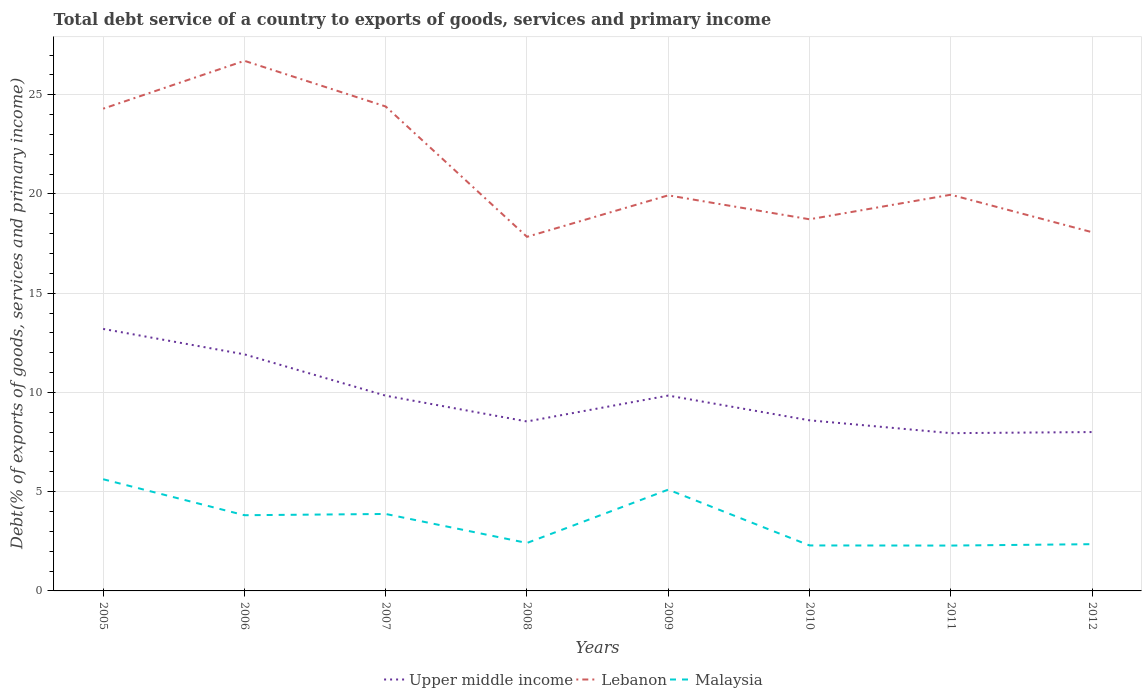Does the line corresponding to Upper middle income intersect with the line corresponding to Malaysia?
Keep it short and to the point. No. Across all years, what is the maximum total debt service in Lebanon?
Offer a very short reply. 17.84. What is the total total debt service in Lebanon in the graph?
Offer a terse response. -0.23. What is the difference between the highest and the second highest total debt service in Upper middle income?
Your answer should be compact. 5.25. What is the difference between the highest and the lowest total debt service in Malaysia?
Make the answer very short. 4. How many years are there in the graph?
Provide a short and direct response. 8. What is the difference between two consecutive major ticks on the Y-axis?
Provide a short and direct response. 5. Does the graph contain grids?
Ensure brevity in your answer.  Yes. Where does the legend appear in the graph?
Keep it short and to the point. Bottom center. How many legend labels are there?
Your response must be concise. 3. What is the title of the graph?
Your answer should be very brief. Total debt service of a country to exports of goods, services and primary income. What is the label or title of the X-axis?
Provide a short and direct response. Years. What is the label or title of the Y-axis?
Provide a succinct answer. Debt(% of exports of goods, services and primary income). What is the Debt(% of exports of goods, services and primary income) of Upper middle income in 2005?
Your answer should be very brief. 13.2. What is the Debt(% of exports of goods, services and primary income) in Lebanon in 2005?
Your response must be concise. 24.3. What is the Debt(% of exports of goods, services and primary income) in Malaysia in 2005?
Provide a short and direct response. 5.63. What is the Debt(% of exports of goods, services and primary income) in Upper middle income in 2006?
Offer a terse response. 11.92. What is the Debt(% of exports of goods, services and primary income) of Lebanon in 2006?
Provide a short and direct response. 26.71. What is the Debt(% of exports of goods, services and primary income) in Malaysia in 2006?
Keep it short and to the point. 3.81. What is the Debt(% of exports of goods, services and primary income) of Upper middle income in 2007?
Your answer should be very brief. 9.84. What is the Debt(% of exports of goods, services and primary income) in Lebanon in 2007?
Your answer should be compact. 24.41. What is the Debt(% of exports of goods, services and primary income) of Malaysia in 2007?
Keep it short and to the point. 3.88. What is the Debt(% of exports of goods, services and primary income) of Upper middle income in 2008?
Your answer should be compact. 8.54. What is the Debt(% of exports of goods, services and primary income) in Lebanon in 2008?
Provide a succinct answer. 17.84. What is the Debt(% of exports of goods, services and primary income) of Malaysia in 2008?
Provide a short and direct response. 2.42. What is the Debt(% of exports of goods, services and primary income) of Upper middle income in 2009?
Your answer should be compact. 9.84. What is the Debt(% of exports of goods, services and primary income) in Lebanon in 2009?
Offer a very short reply. 19.93. What is the Debt(% of exports of goods, services and primary income) in Malaysia in 2009?
Ensure brevity in your answer.  5.1. What is the Debt(% of exports of goods, services and primary income) of Upper middle income in 2010?
Your response must be concise. 8.6. What is the Debt(% of exports of goods, services and primary income) of Lebanon in 2010?
Offer a very short reply. 18.72. What is the Debt(% of exports of goods, services and primary income) of Malaysia in 2010?
Your answer should be compact. 2.29. What is the Debt(% of exports of goods, services and primary income) in Upper middle income in 2011?
Provide a short and direct response. 7.95. What is the Debt(% of exports of goods, services and primary income) in Lebanon in 2011?
Keep it short and to the point. 19.96. What is the Debt(% of exports of goods, services and primary income) in Malaysia in 2011?
Your answer should be very brief. 2.29. What is the Debt(% of exports of goods, services and primary income) of Upper middle income in 2012?
Make the answer very short. 8. What is the Debt(% of exports of goods, services and primary income) of Lebanon in 2012?
Keep it short and to the point. 18.07. What is the Debt(% of exports of goods, services and primary income) of Malaysia in 2012?
Ensure brevity in your answer.  2.35. Across all years, what is the maximum Debt(% of exports of goods, services and primary income) of Upper middle income?
Your answer should be very brief. 13.2. Across all years, what is the maximum Debt(% of exports of goods, services and primary income) of Lebanon?
Offer a very short reply. 26.71. Across all years, what is the maximum Debt(% of exports of goods, services and primary income) of Malaysia?
Provide a succinct answer. 5.63. Across all years, what is the minimum Debt(% of exports of goods, services and primary income) in Upper middle income?
Your response must be concise. 7.95. Across all years, what is the minimum Debt(% of exports of goods, services and primary income) of Lebanon?
Your response must be concise. 17.84. Across all years, what is the minimum Debt(% of exports of goods, services and primary income) in Malaysia?
Your response must be concise. 2.29. What is the total Debt(% of exports of goods, services and primary income) of Upper middle income in the graph?
Make the answer very short. 77.88. What is the total Debt(% of exports of goods, services and primary income) in Lebanon in the graph?
Your answer should be very brief. 169.94. What is the total Debt(% of exports of goods, services and primary income) in Malaysia in the graph?
Your answer should be compact. 27.77. What is the difference between the Debt(% of exports of goods, services and primary income) of Upper middle income in 2005 and that in 2006?
Ensure brevity in your answer.  1.28. What is the difference between the Debt(% of exports of goods, services and primary income) of Lebanon in 2005 and that in 2006?
Ensure brevity in your answer.  -2.41. What is the difference between the Debt(% of exports of goods, services and primary income) of Malaysia in 2005 and that in 2006?
Provide a short and direct response. 1.81. What is the difference between the Debt(% of exports of goods, services and primary income) of Upper middle income in 2005 and that in 2007?
Provide a short and direct response. 3.36. What is the difference between the Debt(% of exports of goods, services and primary income) in Lebanon in 2005 and that in 2007?
Provide a short and direct response. -0.11. What is the difference between the Debt(% of exports of goods, services and primary income) of Malaysia in 2005 and that in 2007?
Your answer should be compact. 1.75. What is the difference between the Debt(% of exports of goods, services and primary income) of Upper middle income in 2005 and that in 2008?
Your response must be concise. 4.66. What is the difference between the Debt(% of exports of goods, services and primary income) in Lebanon in 2005 and that in 2008?
Make the answer very short. 6.46. What is the difference between the Debt(% of exports of goods, services and primary income) of Malaysia in 2005 and that in 2008?
Your answer should be very brief. 3.21. What is the difference between the Debt(% of exports of goods, services and primary income) in Upper middle income in 2005 and that in 2009?
Your answer should be very brief. 3.36. What is the difference between the Debt(% of exports of goods, services and primary income) of Lebanon in 2005 and that in 2009?
Offer a very short reply. 4.37. What is the difference between the Debt(% of exports of goods, services and primary income) in Malaysia in 2005 and that in 2009?
Offer a very short reply. 0.52. What is the difference between the Debt(% of exports of goods, services and primary income) of Upper middle income in 2005 and that in 2010?
Ensure brevity in your answer.  4.6. What is the difference between the Debt(% of exports of goods, services and primary income) of Lebanon in 2005 and that in 2010?
Keep it short and to the point. 5.57. What is the difference between the Debt(% of exports of goods, services and primary income) of Malaysia in 2005 and that in 2010?
Provide a succinct answer. 3.34. What is the difference between the Debt(% of exports of goods, services and primary income) in Upper middle income in 2005 and that in 2011?
Give a very brief answer. 5.25. What is the difference between the Debt(% of exports of goods, services and primary income) of Lebanon in 2005 and that in 2011?
Your response must be concise. 4.33. What is the difference between the Debt(% of exports of goods, services and primary income) of Malaysia in 2005 and that in 2011?
Offer a very short reply. 3.34. What is the difference between the Debt(% of exports of goods, services and primary income) in Upper middle income in 2005 and that in 2012?
Keep it short and to the point. 5.2. What is the difference between the Debt(% of exports of goods, services and primary income) in Lebanon in 2005 and that in 2012?
Make the answer very short. 6.22. What is the difference between the Debt(% of exports of goods, services and primary income) in Malaysia in 2005 and that in 2012?
Provide a short and direct response. 3.27. What is the difference between the Debt(% of exports of goods, services and primary income) in Upper middle income in 2006 and that in 2007?
Offer a very short reply. 2.08. What is the difference between the Debt(% of exports of goods, services and primary income) of Lebanon in 2006 and that in 2007?
Offer a very short reply. 2.3. What is the difference between the Debt(% of exports of goods, services and primary income) in Malaysia in 2006 and that in 2007?
Keep it short and to the point. -0.06. What is the difference between the Debt(% of exports of goods, services and primary income) in Upper middle income in 2006 and that in 2008?
Your answer should be compact. 3.38. What is the difference between the Debt(% of exports of goods, services and primary income) in Lebanon in 2006 and that in 2008?
Offer a terse response. 8.87. What is the difference between the Debt(% of exports of goods, services and primary income) in Malaysia in 2006 and that in 2008?
Your answer should be very brief. 1.4. What is the difference between the Debt(% of exports of goods, services and primary income) of Upper middle income in 2006 and that in 2009?
Keep it short and to the point. 2.08. What is the difference between the Debt(% of exports of goods, services and primary income) of Lebanon in 2006 and that in 2009?
Offer a terse response. 6.78. What is the difference between the Debt(% of exports of goods, services and primary income) of Malaysia in 2006 and that in 2009?
Ensure brevity in your answer.  -1.29. What is the difference between the Debt(% of exports of goods, services and primary income) in Upper middle income in 2006 and that in 2010?
Offer a very short reply. 3.32. What is the difference between the Debt(% of exports of goods, services and primary income) in Lebanon in 2006 and that in 2010?
Ensure brevity in your answer.  7.98. What is the difference between the Debt(% of exports of goods, services and primary income) of Malaysia in 2006 and that in 2010?
Your answer should be very brief. 1.52. What is the difference between the Debt(% of exports of goods, services and primary income) in Upper middle income in 2006 and that in 2011?
Provide a short and direct response. 3.97. What is the difference between the Debt(% of exports of goods, services and primary income) of Lebanon in 2006 and that in 2011?
Offer a very short reply. 6.75. What is the difference between the Debt(% of exports of goods, services and primary income) of Malaysia in 2006 and that in 2011?
Your answer should be compact. 1.53. What is the difference between the Debt(% of exports of goods, services and primary income) of Upper middle income in 2006 and that in 2012?
Give a very brief answer. 3.91. What is the difference between the Debt(% of exports of goods, services and primary income) of Lebanon in 2006 and that in 2012?
Provide a succinct answer. 8.63. What is the difference between the Debt(% of exports of goods, services and primary income) in Malaysia in 2006 and that in 2012?
Keep it short and to the point. 1.46. What is the difference between the Debt(% of exports of goods, services and primary income) in Upper middle income in 2007 and that in 2008?
Provide a succinct answer. 1.3. What is the difference between the Debt(% of exports of goods, services and primary income) in Lebanon in 2007 and that in 2008?
Offer a very short reply. 6.57. What is the difference between the Debt(% of exports of goods, services and primary income) in Malaysia in 2007 and that in 2008?
Offer a very short reply. 1.46. What is the difference between the Debt(% of exports of goods, services and primary income) of Upper middle income in 2007 and that in 2009?
Offer a terse response. -0.01. What is the difference between the Debt(% of exports of goods, services and primary income) in Lebanon in 2007 and that in 2009?
Keep it short and to the point. 4.48. What is the difference between the Debt(% of exports of goods, services and primary income) in Malaysia in 2007 and that in 2009?
Ensure brevity in your answer.  -1.23. What is the difference between the Debt(% of exports of goods, services and primary income) in Upper middle income in 2007 and that in 2010?
Give a very brief answer. 1.24. What is the difference between the Debt(% of exports of goods, services and primary income) of Lebanon in 2007 and that in 2010?
Provide a short and direct response. 5.68. What is the difference between the Debt(% of exports of goods, services and primary income) in Malaysia in 2007 and that in 2010?
Provide a short and direct response. 1.59. What is the difference between the Debt(% of exports of goods, services and primary income) in Upper middle income in 2007 and that in 2011?
Your answer should be very brief. 1.89. What is the difference between the Debt(% of exports of goods, services and primary income) in Lebanon in 2007 and that in 2011?
Make the answer very short. 4.45. What is the difference between the Debt(% of exports of goods, services and primary income) in Malaysia in 2007 and that in 2011?
Your response must be concise. 1.59. What is the difference between the Debt(% of exports of goods, services and primary income) in Upper middle income in 2007 and that in 2012?
Your response must be concise. 1.83. What is the difference between the Debt(% of exports of goods, services and primary income) in Lebanon in 2007 and that in 2012?
Your answer should be compact. 6.33. What is the difference between the Debt(% of exports of goods, services and primary income) of Malaysia in 2007 and that in 2012?
Your answer should be compact. 1.52. What is the difference between the Debt(% of exports of goods, services and primary income) of Upper middle income in 2008 and that in 2009?
Provide a succinct answer. -1.3. What is the difference between the Debt(% of exports of goods, services and primary income) of Lebanon in 2008 and that in 2009?
Give a very brief answer. -2.09. What is the difference between the Debt(% of exports of goods, services and primary income) in Malaysia in 2008 and that in 2009?
Your answer should be compact. -2.69. What is the difference between the Debt(% of exports of goods, services and primary income) in Upper middle income in 2008 and that in 2010?
Ensure brevity in your answer.  -0.06. What is the difference between the Debt(% of exports of goods, services and primary income) of Lebanon in 2008 and that in 2010?
Make the answer very short. -0.88. What is the difference between the Debt(% of exports of goods, services and primary income) of Malaysia in 2008 and that in 2010?
Make the answer very short. 0.12. What is the difference between the Debt(% of exports of goods, services and primary income) of Upper middle income in 2008 and that in 2011?
Your response must be concise. 0.59. What is the difference between the Debt(% of exports of goods, services and primary income) of Lebanon in 2008 and that in 2011?
Ensure brevity in your answer.  -2.12. What is the difference between the Debt(% of exports of goods, services and primary income) of Malaysia in 2008 and that in 2011?
Offer a very short reply. 0.13. What is the difference between the Debt(% of exports of goods, services and primary income) of Upper middle income in 2008 and that in 2012?
Provide a short and direct response. 0.53. What is the difference between the Debt(% of exports of goods, services and primary income) of Lebanon in 2008 and that in 2012?
Your response must be concise. -0.23. What is the difference between the Debt(% of exports of goods, services and primary income) of Malaysia in 2008 and that in 2012?
Ensure brevity in your answer.  0.06. What is the difference between the Debt(% of exports of goods, services and primary income) of Upper middle income in 2009 and that in 2010?
Your answer should be compact. 1.25. What is the difference between the Debt(% of exports of goods, services and primary income) of Lebanon in 2009 and that in 2010?
Offer a very short reply. 1.21. What is the difference between the Debt(% of exports of goods, services and primary income) of Malaysia in 2009 and that in 2010?
Make the answer very short. 2.81. What is the difference between the Debt(% of exports of goods, services and primary income) in Upper middle income in 2009 and that in 2011?
Keep it short and to the point. 1.89. What is the difference between the Debt(% of exports of goods, services and primary income) in Lebanon in 2009 and that in 2011?
Your answer should be very brief. -0.03. What is the difference between the Debt(% of exports of goods, services and primary income) in Malaysia in 2009 and that in 2011?
Your answer should be compact. 2.82. What is the difference between the Debt(% of exports of goods, services and primary income) of Upper middle income in 2009 and that in 2012?
Give a very brief answer. 1.84. What is the difference between the Debt(% of exports of goods, services and primary income) in Lebanon in 2009 and that in 2012?
Offer a terse response. 1.86. What is the difference between the Debt(% of exports of goods, services and primary income) in Malaysia in 2009 and that in 2012?
Give a very brief answer. 2.75. What is the difference between the Debt(% of exports of goods, services and primary income) in Upper middle income in 2010 and that in 2011?
Make the answer very short. 0.65. What is the difference between the Debt(% of exports of goods, services and primary income) of Lebanon in 2010 and that in 2011?
Provide a succinct answer. -1.24. What is the difference between the Debt(% of exports of goods, services and primary income) in Malaysia in 2010 and that in 2011?
Ensure brevity in your answer.  0.01. What is the difference between the Debt(% of exports of goods, services and primary income) of Upper middle income in 2010 and that in 2012?
Keep it short and to the point. 0.59. What is the difference between the Debt(% of exports of goods, services and primary income) of Lebanon in 2010 and that in 2012?
Offer a very short reply. 0.65. What is the difference between the Debt(% of exports of goods, services and primary income) in Malaysia in 2010 and that in 2012?
Keep it short and to the point. -0.06. What is the difference between the Debt(% of exports of goods, services and primary income) of Upper middle income in 2011 and that in 2012?
Ensure brevity in your answer.  -0.06. What is the difference between the Debt(% of exports of goods, services and primary income) in Lebanon in 2011 and that in 2012?
Offer a terse response. 1.89. What is the difference between the Debt(% of exports of goods, services and primary income) in Malaysia in 2011 and that in 2012?
Ensure brevity in your answer.  -0.07. What is the difference between the Debt(% of exports of goods, services and primary income) of Upper middle income in 2005 and the Debt(% of exports of goods, services and primary income) of Lebanon in 2006?
Offer a terse response. -13.51. What is the difference between the Debt(% of exports of goods, services and primary income) in Upper middle income in 2005 and the Debt(% of exports of goods, services and primary income) in Malaysia in 2006?
Your answer should be compact. 9.39. What is the difference between the Debt(% of exports of goods, services and primary income) in Lebanon in 2005 and the Debt(% of exports of goods, services and primary income) in Malaysia in 2006?
Give a very brief answer. 20.48. What is the difference between the Debt(% of exports of goods, services and primary income) in Upper middle income in 2005 and the Debt(% of exports of goods, services and primary income) in Lebanon in 2007?
Offer a terse response. -11.21. What is the difference between the Debt(% of exports of goods, services and primary income) in Upper middle income in 2005 and the Debt(% of exports of goods, services and primary income) in Malaysia in 2007?
Make the answer very short. 9.32. What is the difference between the Debt(% of exports of goods, services and primary income) in Lebanon in 2005 and the Debt(% of exports of goods, services and primary income) in Malaysia in 2007?
Provide a short and direct response. 20.42. What is the difference between the Debt(% of exports of goods, services and primary income) of Upper middle income in 2005 and the Debt(% of exports of goods, services and primary income) of Lebanon in 2008?
Offer a terse response. -4.64. What is the difference between the Debt(% of exports of goods, services and primary income) of Upper middle income in 2005 and the Debt(% of exports of goods, services and primary income) of Malaysia in 2008?
Your answer should be compact. 10.78. What is the difference between the Debt(% of exports of goods, services and primary income) of Lebanon in 2005 and the Debt(% of exports of goods, services and primary income) of Malaysia in 2008?
Ensure brevity in your answer.  21.88. What is the difference between the Debt(% of exports of goods, services and primary income) in Upper middle income in 2005 and the Debt(% of exports of goods, services and primary income) in Lebanon in 2009?
Your answer should be compact. -6.73. What is the difference between the Debt(% of exports of goods, services and primary income) of Upper middle income in 2005 and the Debt(% of exports of goods, services and primary income) of Malaysia in 2009?
Your answer should be very brief. 8.1. What is the difference between the Debt(% of exports of goods, services and primary income) of Lebanon in 2005 and the Debt(% of exports of goods, services and primary income) of Malaysia in 2009?
Your response must be concise. 19.19. What is the difference between the Debt(% of exports of goods, services and primary income) of Upper middle income in 2005 and the Debt(% of exports of goods, services and primary income) of Lebanon in 2010?
Keep it short and to the point. -5.52. What is the difference between the Debt(% of exports of goods, services and primary income) of Upper middle income in 2005 and the Debt(% of exports of goods, services and primary income) of Malaysia in 2010?
Keep it short and to the point. 10.91. What is the difference between the Debt(% of exports of goods, services and primary income) in Lebanon in 2005 and the Debt(% of exports of goods, services and primary income) in Malaysia in 2010?
Keep it short and to the point. 22. What is the difference between the Debt(% of exports of goods, services and primary income) in Upper middle income in 2005 and the Debt(% of exports of goods, services and primary income) in Lebanon in 2011?
Offer a very short reply. -6.76. What is the difference between the Debt(% of exports of goods, services and primary income) in Upper middle income in 2005 and the Debt(% of exports of goods, services and primary income) in Malaysia in 2011?
Your answer should be very brief. 10.91. What is the difference between the Debt(% of exports of goods, services and primary income) in Lebanon in 2005 and the Debt(% of exports of goods, services and primary income) in Malaysia in 2011?
Offer a terse response. 22.01. What is the difference between the Debt(% of exports of goods, services and primary income) in Upper middle income in 2005 and the Debt(% of exports of goods, services and primary income) in Lebanon in 2012?
Provide a short and direct response. -4.87. What is the difference between the Debt(% of exports of goods, services and primary income) in Upper middle income in 2005 and the Debt(% of exports of goods, services and primary income) in Malaysia in 2012?
Keep it short and to the point. 10.85. What is the difference between the Debt(% of exports of goods, services and primary income) of Lebanon in 2005 and the Debt(% of exports of goods, services and primary income) of Malaysia in 2012?
Keep it short and to the point. 21.94. What is the difference between the Debt(% of exports of goods, services and primary income) in Upper middle income in 2006 and the Debt(% of exports of goods, services and primary income) in Lebanon in 2007?
Make the answer very short. -12.49. What is the difference between the Debt(% of exports of goods, services and primary income) of Upper middle income in 2006 and the Debt(% of exports of goods, services and primary income) of Malaysia in 2007?
Provide a short and direct response. 8.04. What is the difference between the Debt(% of exports of goods, services and primary income) in Lebanon in 2006 and the Debt(% of exports of goods, services and primary income) in Malaysia in 2007?
Offer a terse response. 22.83. What is the difference between the Debt(% of exports of goods, services and primary income) of Upper middle income in 2006 and the Debt(% of exports of goods, services and primary income) of Lebanon in 2008?
Give a very brief answer. -5.92. What is the difference between the Debt(% of exports of goods, services and primary income) in Upper middle income in 2006 and the Debt(% of exports of goods, services and primary income) in Malaysia in 2008?
Your response must be concise. 9.5. What is the difference between the Debt(% of exports of goods, services and primary income) in Lebanon in 2006 and the Debt(% of exports of goods, services and primary income) in Malaysia in 2008?
Your response must be concise. 24.29. What is the difference between the Debt(% of exports of goods, services and primary income) in Upper middle income in 2006 and the Debt(% of exports of goods, services and primary income) in Lebanon in 2009?
Provide a short and direct response. -8.01. What is the difference between the Debt(% of exports of goods, services and primary income) of Upper middle income in 2006 and the Debt(% of exports of goods, services and primary income) of Malaysia in 2009?
Give a very brief answer. 6.82. What is the difference between the Debt(% of exports of goods, services and primary income) of Lebanon in 2006 and the Debt(% of exports of goods, services and primary income) of Malaysia in 2009?
Offer a very short reply. 21.6. What is the difference between the Debt(% of exports of goods, services and primary income) in Upper middle income in 2006 and the Debt(% of exports of goods, services and primary income) in Lebanon in 2010?
Give a very brief answer. -6.81. What is the difference between the Debt(% of exports of goods, services and primary income) in Upper middle income in 2006 and the Debt(% of exports of goods, services and primary income) in Malaysia in 2010?
Give a very brief answer. 9.63. What is the difference between the Debt(% of exports of goods, services and primary income) in Lebanon in 2006 and the Debt(% of exports of goods, services and primary income) in Malaysia in 2010?
Your answer should be very brief. 24.42. What is the difference between the Debt(% of exports of goods, services and primary income) of Upper middle income in 2006 and the Debt(% of exports of goods, services and primary income) of Lebanon in 2011?
Provide a succinct answer. -8.04. What is the difference between the Debt(% of exports of goods, services and primary income) of Upper middle income in 2006 and the Debt(% of exports of goods, services and primary income) of Malaysia in 2011?
Keep it short and to the point. 9.63. What is the difference between the Debt(% of exports of goods, services and primary income) of Lebanon in 2006 and the Debt(% of exports of goods, services and primary income) of Malaysia in 2011?
Make the answer very short. 24.42. What is the difference between the Debt(% of exports of goods, services and primary income) of Upper middle income in 2006 and the Debt(% of exports of goods, services and primary income) of Lebanon in 2012?
Your response must be concise. -6.15. What is the difference between the Debt(% of exports of goods, services and primary income) of Upper middle income in 2006 and the Debt(% of exports of goods, services and primary income) of Malaysia in 2012?
Ensure brevity in your answer.  9.56. What is the difference between the Debt(% of exports of goods, services and primary income) of Lebanon in 2006 and the Debt(% of exports of goods, services and primary income) of Malaysia in 2012?
Provide a short and direct response. 24.35. What is the difference between the Debt(% of exports of goods, services and primary income) in Upper middle income in 2007 and the Debt(% of exports of goods, services and primary income) in Lebanon in 2008?
Keep it short and to the point. -8. What is the difference between the Debt(% of exports of goods, services and primary income) of Upper middle income in 2007 and the Debt(% of exports of goods, services and primary income) of Malaysia in 2008?
Provide a short and direct response. 7.42. What is the difference between the Debt(% of exports of goods, services and primary income) in Lebanon in 2007 and the Debt(% of exports of goods, services and primary income) in Malaysia in 2008?
Keep it short and to the point. 21.99. What is the difference between the Debt(% of exports of goods, services and primary income) in Upper middle income in 2007 and the Debt(% of exports of goods, services and primary income) in Lebanon in 2009?
Offer a terse response. -10.09. What is the difference between the Debt(% of exports of goods, services and primary income) in Upper middle income in 2007 and the Debt(% of exports of goods, services and primary income) in Malaysia in 2009?
Give a very brief answer. 4.73. What is the difference between the Debt(% of exports of goods, services and primary income) of Lebanon in 2007 and the Debt(% of exports of goods, services and primary income) of Malaysia in 2009?
Offer a terse response. 19.3. What is the difference between the Debt(% of exports of goods, services and primary income) in Upper middle income in 2007 and the Debt(% of exports of goods, services and primary income) in Lebanon in 2010?
Ensure brevity in your answer.  -8.89. What is the difference between the Debt(% of exports of goods, services and primary income) in Upper middle income in 2007 and the Debt(% of exports of goods, services and primary income) in Malaysia in 2010?
Your response must be concise. 7.54. What is the difference between the Debt(% of exports of goods, services and primary income) of Lebanon in 2007 and the Debt(% of exports of goods, services and primary income) of Malaysia in 2010?
Your answer should be compact. 22.12. What is the difference between the Debt(% of exports of goods, services and primary income) in Upper middle income in 2007 and the Debt(% of exports of goods, services and primary income) in Lebanon in 2011?
Your response must be concise. -10.13. What is the difference between the Debt(% of exports of goods, services and primary income) in Upper middle income in 2007 and the Debt(% of exports of goods, services and primary income) in Malaysia in 2011?
Provide a short and direct response. 7.55. What is the difference between the Debt(% of exports of goods, services and primary income) of Lebanon in 2007 and the Debt(% of exports of goods, services and primary income) of Malaysia in 2011?
Your answer should be very brief. 22.12. What is the difference between the Debt(% of exports of goods, services and primary income) of Upper middle income in 2007 and the Debt(% of exports of goods, services and primary income) of Lebanon in 2012?
Offer a terse response. -8.24. What is the difference between the Debt(% of exports of goods, services and primary income) in Upper middle income in 2007 and the Debt(% of exports of goods, services and primary income) in Malaysia in 2012?
Offer a very short reply. 7.48. What is the difference between the Debt(% of exports of goods, services and primary income) in Lebanon in 2007 and the Debt(% of exports of goods, services and primary income) in Malaysia in 2012?
Offer a terse response. 22.05. What is the difference between the Debt(% of exports of goods, services and primary income) in Upper middle income in 2008 and the Debt(% of exports of goods, services and primary income) in Lebanon in 2009?
Offer a terse response. -11.39. What is the difference between the Debt(% of exports of goods, services and primary income) in Upper middle income in 2008 and the Debt(% of exports of goods, services and primary income) in Malaysia in 2009?
Make the answer very short. 3.43. What is the difference between the Debt(% of exports of goods, services and primary income) of Lebanon in 2008 and the Debt(% of exports of goods, services and primary income) of Malaysia in 2009?
Give a very brief answer. 12.74. What is the difference between the Debt(% of exports of goods, services and primary income) of Upper middle income in 2008 and the Debt(% of exports of goods, services and primary income) of Lebanon in 2010?
Provide a succinct answer. -10.19. What is the difference between the Debt(% of exports of goods, services and primary income) in Upper middle income in 2008 and the Debt(% of exports of goods, services and primary income) in Malaysia in 2010?
Make the answer very short. 6.25. What is the difference between the Debt(% of exports of goods, services and primary income) in Lebanon in 2008 and the Debt(% of exports of goods, services and primary income) in Malaysia in 2010?
Provide a short and direct response. 15.55. What is the difference between the Debt(% of exports of goods, services and primary income) in Upper middle income in 2008 and the Debt(% of exports of goods, services and primary income) in Lebanon in 2011?
Make the answer very short. -11.42. What is the difference between the Debt(% of exports of goods, services and primary income) in Upper middle income in 2008 and the Debt(% of exports of goods, services and primary income) in Malaysia in 2011?
Provide a succinct answer. 6.25. What is the difference between the Debt(% of exports of goods, services and primary income) of Lebanon in 2008 and the Debt(% of exports of goods, services and primary income) of Malaysia in 2011?
Your answer should be very brief. 15.55. What is the difference between the Debt(% of exports of goods, services and primary income) in Upper middle income in 2008 and the Debt(% of exports of goods, services and primary income) in Lebanon in 2012?
Offer a very short reply. -9.54. What is the difference between the Debt(% of exports of goods, services and primary income) in Upper middle income in 2008 and the Debt(% of exports of goods, services and primary income) in Malaysia in 2012?
Provide a succinct answer. 6.18. What is the difference between the Debt(% of exports of goods, services and primary income) of Lebanon in 2008 and the Debt(% of exports of goods, services and primary income) of Malaysia in 2012?
Your response must be concise. 15.49. What is the difference between the Debt(% of exports of goods, services and primary income) in Upper middle income in 2009 and the Debt(% of exports of goods, services and primary income) in Lebanon in 2010?
Your answer should be very brief. -8.88. What is the difference between the Debt(% of exports of goods, services and primary income) in Upper middle income in 2009 and the Debt(% of exports of goods, services and primary income) in Malaysia in 2010?
Provide a short and direct response. 7.55. What is the difference between the Debt(% of exports of goods, services and primary income) of Lebanon in 2009 and the Debt(% of exports of goods, services and primary income) of Malaysia in 2010?
Offer a terse response. 17.64. What is the difference between the Debt(% of exports of goods, services and primary income) in Upper middle income in 2009 and the Debt(% of exports of goods, services and primary income) in Lebanon in 2011?
Your answer should be compact. -10.12. What is the difference between the Debt(% of exports of goods, services and primary income) in Upper middle income in 2009 and the Debt(% of exports of goods, services and primary income) in Malaysia in 2011?
Your answer should be very brief. 7.56. What is the difference between the Debt(% of exports of goods, services and primary income) in Lebanon in 2009 and the Debt(% of exports of goods, services and primary income) in Malaysia in 2011?
Offer a very short reply. 17.65. What is the difference between the Debt(% of exports of goods, services and primary income) of Upper middle income in 2009 and the Debt(% of exports of goods, services and primary income) of Lebanon in 2012?
Keep it short and to the point. -8.23. What is the difference between the Debt(% of exports of goods, services and primary income) of Upper middle income in 2009 and the Debt(% of exports of goods, services and primary income) of Malaysia in 2012?
Offer a very short reply. 7.49. What is the difference between the Debt(% of exports of goods, services and primary income) of Lebanon in 2009 and the Debt(% of exports of goods, services and primary income) of Malaysia in 2012?
Ensure brevity in your answer.  17.58. What is the difference between the Debt(% of exports of goods, services and primary income) in Upper middle income in 2010 and the Debt(% of exports of goods, services and primary income) in Lebanon in 2011?
Ensure brevity in your answer.  -11.37. What is the difference between the Debt(% of exports of goods, services and primary income) of Upper middle income in 2010 and the Debt(% of exports of goods, services and primary income) of Malaysia in 2011?
Offer a terse response. 6.31. What is the difference between the Debt(% of exports of goods, services and primary income) in Lebanon in 2010 and the Debt(% of exports of goods, services and primary income) in Malaysia in 2011?
Ensure brevity in your answer.  16.44. What is the difference between the Debt(% of exports of goods, services and primary income) of Upper middle income in 2010 and the Debt(% of exports of goods, services and primary income) of Lebanon in 2012?
Provide a short and direct response. -9.48. What is the difference between the Debt(% of exports of goods, services and primary income) in Upper middle income in 2010 and the Debt(% of exports of goods, services and primary income) in Malaysia in 2012?
Offer a terse response. 6.24. What is the difference between the Debt(% of exports of goods, services and primary income) in Lebanon in 2010 and the Debt(% of exports of goods, services and primary income) in Malaysia in 2012?
Give a very brief answer. 16.37. What is the difference between the Debt(% of exports of goods, services and primary income) in Upper middle income in 2011 and the Debt(% of exports of goods, services and primary income) in Lebanon in 2012?
Give a very brief answer. -10.13. What is the difference between the Debt(% of exports of goods, services and primary income) of Upper middle income in 2011 and the Debt(% of exports of goods, services and primary income) of Malaysia in 2012?
Offer a very short reply. 5.59. What is the difference between the Debt(% of exports of goods, services and primary income) in Lebanon in 2011 and the Debt(% of exports of goods, services and primary income) in Malaysia in 2012?
Give a very brief answer. 17.61. What is the average Debt(% of exports of goods, services and primary income) of Upper middle income per year?
Ensure brevity in your answer.  9.74. What is the average Debt(% of exports of goods, services and primary income) of Lebanon per year?
Your answer should be compact. 21.24. What is the average Debt(% of exports of goods, services and primary income) in Malaysia per year?
Provide a short and direct response. 3.47. In the year 2005, what is the difference between the Debt(% of exports of goods, services and primary income) of Upper middle income and Debt(% of exports of goods, services and primary income) of Lebanon?
Provide a short and direct response. -11.1. In the year 2005, what is the difference between the Debt(% of exports of goods, services and primary income) in Upper middle income and Debt(% of exports of goods, services and primary income) in Malaysia?
Make the answer very short. 7.57. In the year 2005, what is the difference between the Debt(% of exports of goods, services and primary income) of Lebanon and Debt(% of exports of goods, services and primary income) of Malaysia?
Offer a very short reply. 18.67. In the year 2006, what is the difference between the Debt(% of exports of goods, services and primary income) of Upper middle income and Debt(% of exports of goods, services and primary income) of Lebanon?
Offer a terse response. -14.79. In the year 2006, what is the difference between the Debt(% of exports of goods, services and primary income) in Upper middle income and Debt(% of exports of goods, services and primary income) in Malaysia?
Offer a very short reply. 8.1. In the year 2006, what is the difference between the Debt(% of exports of goods, services and primary income) of Lebanon and Debt(% of exports of goods, services and primary income) of Malaysia?
Offer a very short reply. 22.89. In the year 2007, what is the difference between the Debt(% of exports of goods, services and primary income) of Upper middle income and Debt(% of exports of goods, services and primary income) of Lebanon?
Your response must be concise. -14.57. In the year 2007, what is the difference between the Debt(% of exports of goods, services and primary income) in Upper middle income and Debt(% of exports of goods, services and primary income) in Malaysia?
Ensure brevity in your answer.  5.96. In the year 2007, what is the difference between the Debt(% of exports of goods, services and primary income) of Lebanon and Debt(% of exports of goods, services and primary income) of Malaysia?
Your response must be concise. 20.53. In the year 2008, what is the difference between the Debt(% of exports of goods, services and primary income) in Upper middle income and Debt(% of exports of goods, services and primary income) in Lebanon?
Give a very brief answer. -9.3. In the year 2008, what is the difference between the Debt(% of exports of goods, services and primary income) in Upper middle income and Debt(% of exports of goods, services and primary income) in Malaysia?
Provide a short and direct response. 6.12. In the year 2008, what is the difference between the Debt(% of exports of goods, services and primary income) in Lebanon and Debt(% of exports of goods, services and primary income) in Malaysia?
Offer a terse response. 15.42. In the year 2009, what is the difference between the Debt(% of exports of goods, services and primary income) in Upper middle income and Debt(% of exports of goods, services and primary income) in Lebanon?
Make the answer very short. -10.09. In the year 2009, what is the difference between the Debt(% of exports of goods, services and primary income) in Upper middle income and Debt(% of exports of goods, services and primary income) in Malaysia?
Your answer should be compact. 4.74. In the year 2009, what is the difference between the Debt(% of exports of goods, services and primary income) of Lebanon and Debt(% of exports of goods, services and primary income) of Malaysia?
Your response must be concise. 14.83. In the year 2010, what is the difference between the Debt(% of exports of goods, services and primary income) of Upper middle income and Debt(% of exports of goods, services and primary income) of Lebanon?
Your response must be concise. -10.13. In the year 2010, what is the difference between the Debt(% of exports of goods, services and primary income) of Upper middle income and Debt(% of exports of goods, services and primary income) of Malaysia?
Offer a very short reply. 6.3. In the year 2010, what is the difference between the Debt(% of exports of goods, services and primary income) of Lebanon and Debt(% of exports of goods, services and primary income) of Malaysia?
Keep it short and to the point. 16.43. In the year 2011, what is the difference between the Debt(% of exports of goods, services and primary income) of Upper middle income and Debt(% of exports of goods, services and primary income) of Lebanon?
Give a very brief answer. -12.01. In the year 2011, what is the difference between the Debt(% of exports of goods, services and primary income) of Upper middle income and Debt(% of exports of goods, services and primary income) of Malaysia?
Make the answer very short. 5.66. In the year 2011, what is the difference between the Debt(% of exports of goods, services and primary income) of Lebanon and Debt(% of exports of goods, services and primary income) of Malaysia?
Ensure brevity in your answer.  17.68. In the year 2012, what is the difference between the Debt(% of exports of goods, services and primary income) in Upper middle income and Debt(% of exports of goods, services and primary income) in Lebanon?
Offer a very short reply. -10.07. In the year 2012, what is the difference between the Debt(% of exports of goods, services and primary income) in Upper middle income and Debt(% of exports of goods, services and primary income) in Malaysia?
Ensure brevity in your answer.  5.65. In the year 2012, what is the difference between the Debt(% of exports of goods, services and primary income) of Lebanon and Debt(% of exports of goods, services and primary income) of Malaysia?
Your answer should be very brief. 15.72. What is the ratio of the Debt(% of exports of goods, services and primary income) in Upper middle income in 2005 to that in 2006?
Give a very brief answer. 1.11. What is the ratio of the Debt(% of exports of goods, services and primary income) of Lebanon in 2005 to that in 2006?
Your answer should be compact. 0.91. What is the ratio of the Debt(% of exports of goods, services and primary income) in Malaysia in 2005 to that in 2006?
Provide a succinct answer. 1.48. What is the ratio of the Debt(% of exports of goods, services and primary income) in Upper middle income in 2005 to that in 2007?
Offer a terse response. 1.34. What is the ratio of the Debt(% of exports of goods, services and primary income) of Lebanon in 2005 to that in 2007?
Make the answer very short. 1. What is the ratio of the Debt(% of exports of goods, services and primary income) of Malaysia in 2005 to that in 2007?
Make the answer very short. 1.45. What is the ratio of the Debt(% of exports of goods, services and primary income) in Upper middle income in 2005 to that in 2008?
Keep it short and to the point. 1.55. What is the ratio of the Debt(% of exports of goods, services and primary income) of Lebanon in 2005 to that in 2008?
Provide a succinct answer. 1.36. What is the ratio of the Debt(% of exports of goods, services and primary income) in Malaysia in 2005 to that in 2008?
Offer a terse response. 2.33. What is the ratio of the Debt(% of exports of goods, services and primary income) of Upper middle income in 2005 to that in 2009?
Provide a succinct answer. 1.34. What is the ratio of the Debt(% of exports of goods, services and primary income) of Lebanon in 2005 to that in 2009?
Provide a succinct answer. 1.22. What is the ratio of the Debt(% of exports of goods, services and primary income) in Malaysia in 2005 to that in 2009?
Offer a very short reply. 1.1. What is the ratio of the Debt(% of exports of goods, services and primary income) of Upper middle income in 2005 to that in 2010?
Make the answer very short. 1.54. What is the ratio of the Debt(% of exports of goods, services and primary income) in Lebanon in 2005 to that in 2010?
Give a very brief answer. 1.3. What is the ratio of the Debt(% of exports of goods, services and primary income) in Malaysia in 2005 to that in 2010?
Your response must be concise. 2.46. What is the ratio of the Debt(% of exports of goods, services and primary income) of Upper middle income in 2005 to that in 2011?
Make the answer very short. 1.66. What is the ratio of the Debt(% of exports of goods, services and primary income) in Lebanon in 2005 to that in 2011?
Your answer should be compact. 1.22. What is the ratio of the Debt(% of exports of goods, services and primary income) in Malaysia in 2005 to that in 2011?
Your answer should be very brief. 2.46. What is the ratio of the Debt(% of exports of goods, services and primary income) in Upper middle income in 2005 to that in 2012?
Give a very brief answer. 1.65. What is the ratio of the Debt(% of exports of goods, services and primary income) in Lebanon in 2005 to that in 2012?
Ensure brevity in your answer.  1.34. What is the ratio of the Debt(% of exports of goods, services and primary income) in Malaysia in 2005 to that in 2012?
Your answer should be very brief. 2.39. What is the ratio of the Debt(% of exports of goods, services and primary income) of Upper middle income in 2006 to that in 2007?
Keep it short and to the point. 1.21. What is the ratio of the Debt(% of exports of goods, services and primary income) of Lebanon in 2006 to that in 2007?
Provide a short and direct response. 1.09. What is the ratio of the Debt(% of exports of goods, services and primary income) of Malaysia in 2006 to that in 2007?
Provide a short and direct response. 0.98. What is the ratio of the Debt(% of exports of goods, services and primary income) in Upper middle income in 2006 to that in 2008?
Provide a short and direct response. 1.4. What is the ratio of the Debt(% of exports of goods, services and primary income) of Lebanon in 2006 to that in 2008?
Offer a terse response. 1.5. What is the ratio of the Debt(% of exports of goods, services and primary income) in Malaysia in 2006 to that in 2008?
Provide a short and direct response. 1.58. What is the ratio of the Debt(% of exports of goods, services and primary income) in Upper middle income in 2006 to that in 2009?
Give a very brief answer. 1.21. What is the ratio of the Debt(% of exports of goods, services and primary income) in Lebanon in 2006 to that in 2009?
Your answer should be compact. 1.34. What is the ratio of the Debt(% of exports of goods, services and primary income) in Malaysia in 2006 to that in 2009?
Ensure brevity in your answer.  0.75. What is the ratio of the Debt(% of exports of goods, services and primary income) of Upper middle income in 2006 to that in 2010?
Provide a succinct answer. 1.39. What is the ratio of the Debt(% of exports of goods, services and primary income) of Lebanon in 2006 to that in 2010?
Your answer should be compact. 1.43. What is the ratio of the Debt(% of exports of goods, services and primary income) in Malaysia in 2006 to that in 2010?
Your answer should be compact. 1.66. What is the ratio of the Debt(% of exports of goods, services and primary income) of Upper middle income in 2006 to that in 2011?
Give a very brief answer. 1.5. What is the ratio of the Debt(% of exports of goods, services and primary income) of Lebanon in 2006 to that in 2011?
Your answer should be very brief. 1.34. What is the ratio of the Debt(% of exports of goods, services and primary income) of Malaysia in 2006 to that in 2011?
Give a very brief answer. 1.67. What is the ratio of the Debt(% of exports of goods, services and primary income) in Upper middle income in 2006 to that in 2012?
Ensure brevity in your answer.  1.49. What is the ratio of the Debt(% of exports of goods, services and primary income) of Lebanon in 2006 to that in 2012?
Keep it short and to the point. 1.48. What is the ratio of the Debt(% of exports of goods, services and primary income) in Malaysia in 2006 to that in 2012?
Your answer should be compact. 1.62. What is the ratio of the Debt(% of exports of goods, services and primary income) in Upper middle income in 2007 to that in 2008?
Give a very brief answer. 1.15. What is the ratio of the Debt(% of exports of goods, services and primary income) in Lebanon in 2007 to that in 2008?
Give a very brief answer. 1.37. What is the ratio of the Debt(% of exports of goods, services and primary income) in Malaysia in 2007 to that in 2008?
Your answer should be very brief. 1.61. What is the ratio of the Debt(% of exports of goods, services and primary income) in Lebanon in 2007 to that in 2009?
Offer a very short reply. 1.22. What is the ratio of the Debt(% of exports of goods, services and primary income) in Malaysia in 2007 to that in 2009?
Offer a terse response. 0.76. What is the ratio of the Debt(% of exports of goods, services and primary income) in Upper middle income in 2007 to that in 2010?
Your response must be concise. 1.14. What is the ratio of the Debt(% of exports of goods, services and primary income) in Lebanon in 2007 to that in 2010?
Make the answer very short. 1.3. What is the ratio of the Debt(% of exports of goods, services and primary income) of Malaysia in 2007 to that in 2010?
Make the answer very short. 1.69. What is the ratio of the Debt(% of exports of goods, services and primary income) in Upper middle income in 2007 to that in 2011?
Provide a succinct answer. 1.24. What is the ratio of the Debt(% of exports of goods, services and primary income) of Lebanon in 2007 to that in 2011?
Provide a succinct answer. 1.22. What is the ratio of the Debt(% of exports of goods, services and primary income) of Malaysia in 2007 to that in 2011?
Offer a terse response. 1.7. What is the ratio of the Debt(% of exports of goods, services and primary income) in Upper middle income in 2007 to that in 2012?
Offer a terse response. 1.23. What is the ratio of the Debt(% of exports of goods, services and primary income) in Lebanon in 2007 to that in 2012?
Offer a very short reply. 1.35. What is the ratio of the Debt(% of exports of goods, services and primary income) of Malaysia in 2007 to that in 2012?
Give a very brief answer. 1.65. What is the ratio of the Debt(% of exports of goods, services and primary income) in Upper middle income in 2008 to that in 2009?
Offer a terse response. 0.87. What is the ratio of the Debt(% of exports of goods, services and primary income) of Lebanon in 2008 to that in 2009?
Your answer should be very brief. 0.9. What is the ratio of the Debt(% of exports of goods, services and primary income) in Malaysia in 2008 to that in 2009?
Your answer should be very brief. 0.47. What is the ratio of the Debt(% of exports of goods, services and primary income) of Lebanon in 2008 to that in 2010?
Your response must be concise. 0.95. What is the ratio of the Debt(% of exports of goods, services and primary income) of Malaysia in 2008 to that in 2010?
Give a very brief answer. 1.05. What is the ratio of the Debt(% of exports of goods, services and primary income) in Upper middle income in 2008 to that in 2011?
Provide a succinct answer. 1.07. What is the ratio of the Debt(% of exports of goods, services and primary income) of Lebanon in 2008 to that in 2011?
Provide a short and direct response. 0.89. What is the ratio of the Debt(% of exports of goods, services and primary income) of Malaysia in 2008 to that in 2011?
Your answer should be very brief. 1.06. What is the ratio of the Debt(% of exports of goods, services and primary income) of Upper middle income in 2008 to that in 2012?
Give a very brief answer. 1.07. What is the ratio of the Debt(% of exports of goods, services and primary income) in Lebanon in 2008 to that in 2012?
Make the answer very short. 0.99. What is the ratio of the Debt(% of exports of goods, services and primary income) of Malaysia in 2008 to that in 2012?
Offer a terse response. 1.03. What is the ratio of the Debt(% of exports of goods, services and primary income) of Upper middle income in 2009 to that in 2010?
Keep it short and to the point. 1.15. What is the ratio of the Debt(% of exports of goods, services and primary income) in Lebanon in 2009 to that in 2010?
Provide a succinct answer. 1.06. What is the ratio of the Debt(% of exports of goods, services and primary income) of Malaysia in 2009 to that in 2010?
Offer a terse response. 2.23. What is the ratio of the Debt(% of exports of goods, services and primary income) of Upper middle income in 2009 to that in 2011?
Your response must be concise. 1.24. What is the ratio of the Debt(% of exports of goods, services and primary income) of Lebanon in 2009 to that in 2011?
Provide a succinct answer. 1. What is the ratio of the Debt(% of exports of goods, services and primary income) of Malaysia in 2009 to that in 2011?
Provide a succinct answer. 2.23. What is the ratio of the Debt(% of exports of goods, services and primary income) in Upper middle income in 2009 to that in 2012?
Offer a very short reply. 1.23. What is the ratio of the Debt(% of exports of goods, services and primary income) in Lebanon in 2009 to that in 2012?
Give a very brief answer. 1.1. What is the ratio of the Debt(% of exports of goods, services and primary income) of Malaysia in 2009 to that in 2012?
Make the answer very short. 2.17. What is the ratio of the Debt(% of exports of goods, services and primary income) of Upper middle income in 2010 to that in 2011?
Give a very brief answer. 1.08. What is the ratio of the Debt(% of exports of goods, services and primary income) in Lebanon in 2010 to that in 2011?
Your response must be concise. 0.94. What is the ratio of the Debt(% of exports of goods, services and primary income) in Upper middle income in 2010 to that in 2012?
Your response must be concise. 1.07. What is the ratio of the Debt(% of exports of goods, services and primary income) of Lebanon in 2010 to that in 2012?
Provide a short and direct response. 1.04. What is the ratio of the Debt(% of exports of goods, services and primary income) in Malaysia in 2010 to that in 2012?
Offer a very short reply. 0.97. What is the ratio of the Debt(% of exports of goods, services and primary income) of Upper middle income in 2011 to that in 2012?
Keep it short and to the point. 0.99. What is the ratio of the Debt(% of exports of goods, services and primary income) of Lebanon in 2011 to that in 2012?
Your response must be concise. 1.1. What is the ratio of the Debt(% of exports of goods, services and primary income) in Malaysia in 2011 to that in 2012?
Give a very brief answer. 0.97. What is the difference between the highest and the second highest Debt(% of exports of goods, services and primary income) in Upper middle income?
Offer a very short reply. 1.28. What is the difference between the highest and the second highest Debt(% of exports of goods, services and primary income) in Lebanon?
Your answer should be very brief. 2.3. What is the difference between the highest and the second highest Debt(% of exports of goods, services and primary income) in Malaysia?
Make the answer very short. 0.52. What is the difference between the highest and the lowest Debt(% of exports of goods, services and primary income) of Upper middle income?
Your answer should be compact. 5.25. What is the difference between the highest and the lowest Debt(% of exports of goods, services and primary income) of Lebanon?
Ensure brevity in your answer.  8.87. What is the difference between the highest and the lowest Debt(% of exports of goods, services and primary income) in Malaysia?
Make the answer very short. 3.34. 